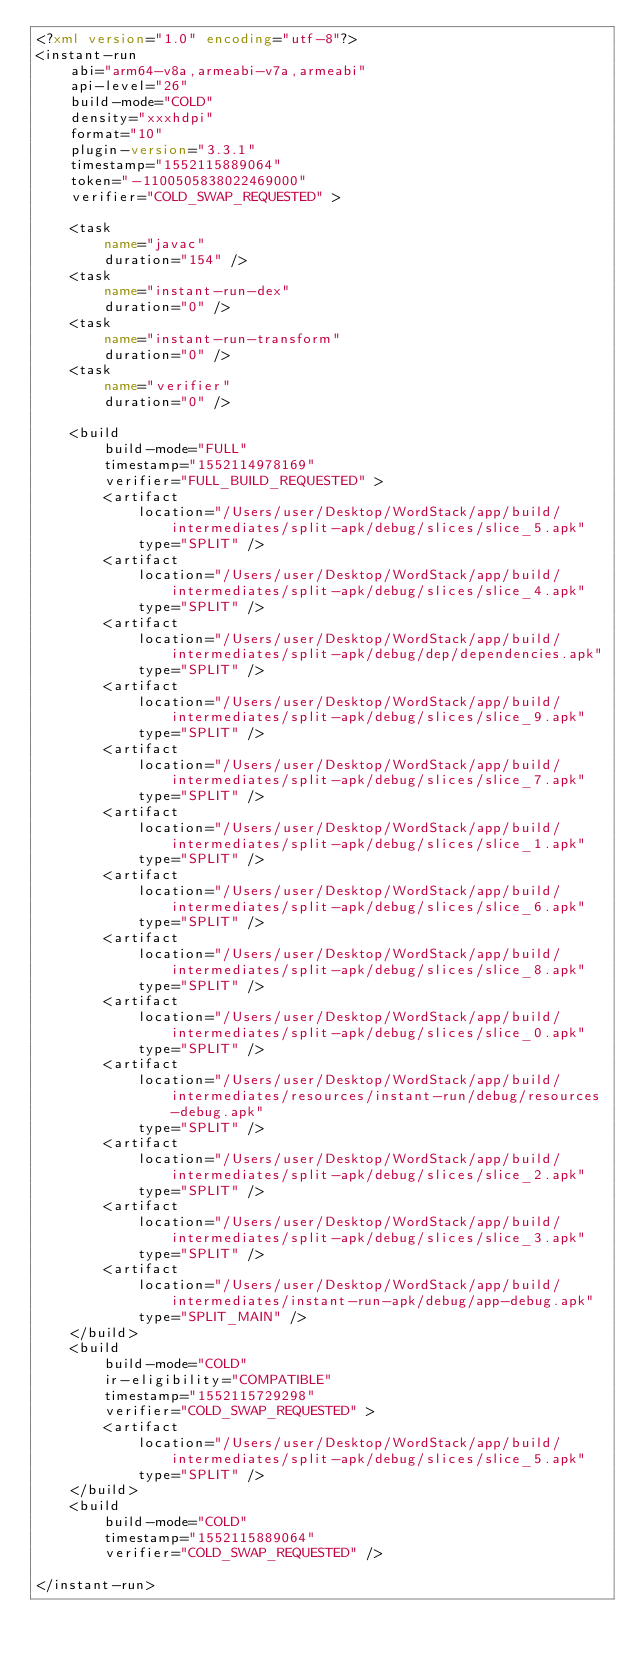Convert code to text. <code><loc_0><loc_0><loc_500><loc_500><_XML_><?xml version="1.0" encoding="utf-8"?>
<instant-run
    abi="arm64-v8a,armeabi-v7a,armeabi"
    api-level="26"
    build-mode="COLD"
    density="xxxhdpi"
    format="10"
    plugin-version="3.3.1"
    timestamp="1552115889064"
    token="-1100505838022469000"
    verifier="COLD_SWAP_REQUESTED" >

    <task
        name="javac"
        duration="154" />
    <task
        name="instant-run-dex"
        duration="0" />
    <task
        name="instant-run-transform"
        duration="0" />
    <task
        name="verifier"
        duration="0" />

    <build
        build-mode="FULL"
        timestamp="1552114978169"
        verifier="FULL_BUILD_REQUESTED" >
        <artifact
            location="/Users/user/Desktop/WordStack/app/build/intermediates/split-apk/debug/slices/slice_5.apk"
            type="SPLIT" />
        <artifact
            location="/Users/user/Desktop/WordStack/app/build/intermediates/split-apk/debug/slices/slice_4.apk"
            type="SPLIT" />
        <artifact
            location="/Users/user/Desktop/WordStack/app/build/intermediates/split-apk/debug/dep/dependencies.apk"
            type="SPLIT" />
        <artifact
            location="/Users/user/Desktop/WordStack/app/build/intermediates/split-apk/debug/slices/slice_9.apk"
            type="SPLIT" />
        <artifact
            location="/Users/user/Desktop/WordStack/app/build/intermediates/split-apk/debug/slices/slice_7.apk"
            type="SPLIT" />
        <artifact
            location="/Users/user/Desktop/WordStack/app/build/intermediates/split-apk/debug/slices/slice_1.apk"
            type="SPLIT" />
        <artifact
            location="/Users/user/Desktop/WordStack/app/build/intermediates/split-apk/debug/slices/slice_6.apk"
            type="SPLIT" />
        <artifact
            location="/Users/user/Desktop/WordStack/app/build/intermediates/split-apk/debug/slices/slice_8.apk"
            type="SPLIT" />
        <artifact
            location="/Users/user/Desktop/WordStack/app/build/intermediates/split-apk/debug/slices/slice_0.apk"
            type="SPLIT" />
        <artifact
            location="/Users/user/Desktop/WordStack/app/build/intermediates/resources/instant-run/debug/resources-debug.apk"
            type="SPLIT" />
        <artifact
            location="/Users/user/Desktop/WordStack/app/build/intermediates/split-apk/debug/slices/slice_2.apk"
            type="SPLIT" />
        <artifact
            location="/Users/user/Desktop/WordStack/app/build/intermediates/split-apk/debug/slices/slice_3.apk"
            type="SPLIT" />
        <artifact
            location="/Users/user/Desktop/WordStack/app/build/intermediates/instant-run-apk/debug/app-debug.apk"
            type="SPLIT_MAIN" />
    </build>
    <build
        build-mode="COLD"
        ir-eligibility="COMPATIBLE"
        timestamp="1552115729298"
        verifier="COLD_SWAP_REQUESTED" >
        <artifact
            location="/Users/user/Desktop/WordStack/app/build/intermediates/split-apk/debug/slices/slice_5.apk"
            type="SPLIT" />
    </build>
    <build
        build-mode="COLD"
        timestamp="1552115889064"
        verifier="COLD_SWAP_REQUESTED" />

</instant-run>
</code> 